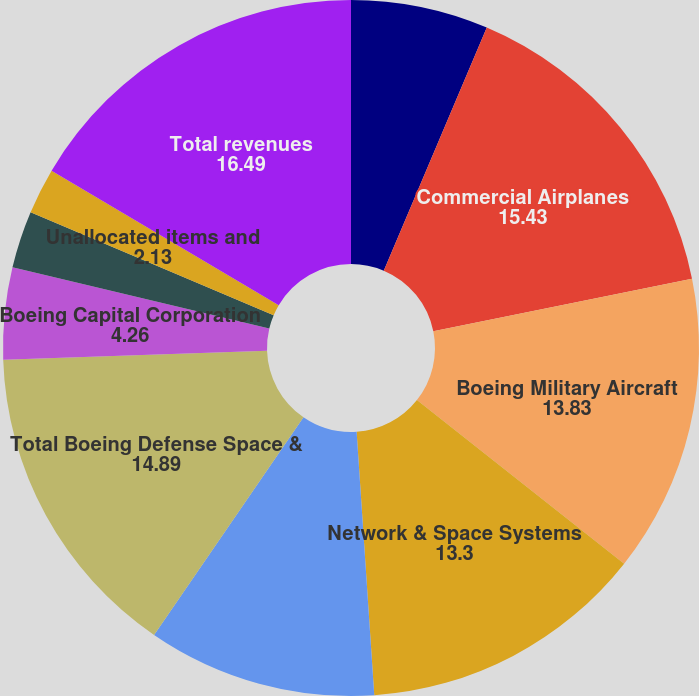Convert chart. <chart><loc_0><loc_0><loc_500><loc_500><pie_chart><fcel>(Dollars in millions except<fcel>Commercial Airplanes<fcel>Boeing Military Aircraft<fcel>Network & Space Systems<fcel>Global Services & Support<fcel>Total Boeing Defense Space &<fcel>Boeing Capital Corporation<fcel>Other segment<fcel>Unallocated items and<fcel>Total revenues<nl><fcel>6.38%<fcel>15.43%<fcel>13.83%<fcel>13.3%<fcel>10.64%<fcel>14.89%<fcel>4.26%<fcel>2.66%<fcel>2.13%<fcel>16.49%<nl></chart> 